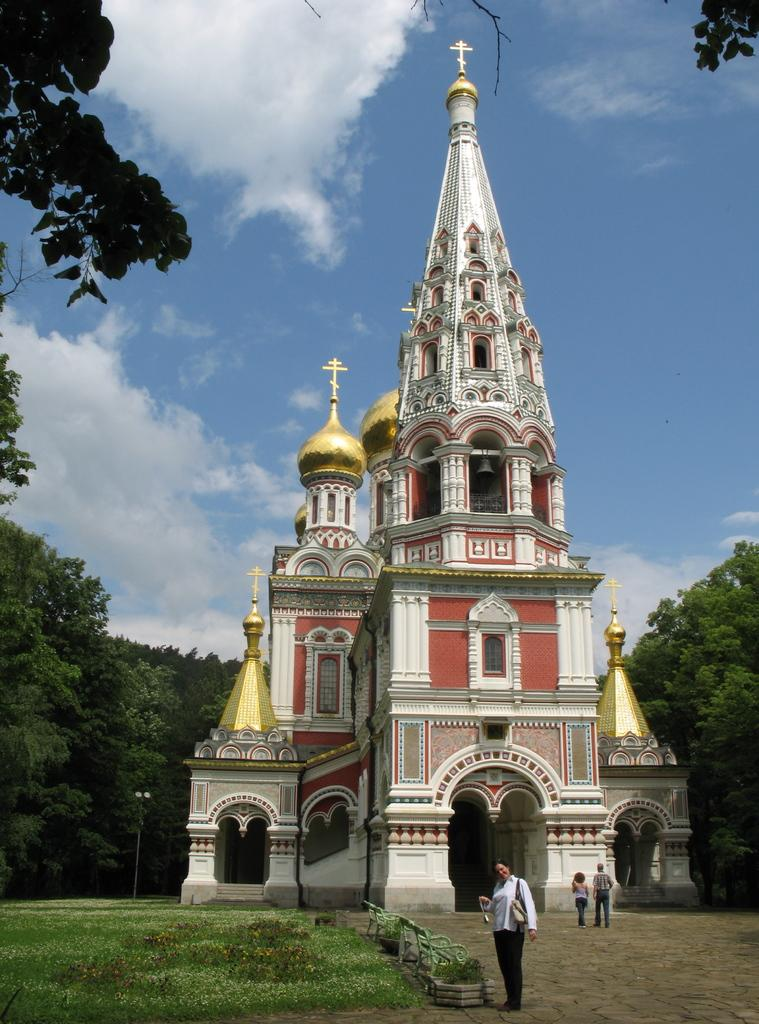How many people are in the image? There are people in the image. What type of natural environment is present in the image? There is grass, ground, trees, and the sky visible in the image. What type of man-made structures can be seen in the image? Ancient architecture is present in the image. What additional object can be seen in the image? There is a pole in the image. What is the condition of the sky in the image? The sky is visible in the background of the image, and clouds are present. Can you tell me how many flowers are depicted in the image? There are no flowers present in the image. Is there a yak visible in the image? There is no yak present in the image. 